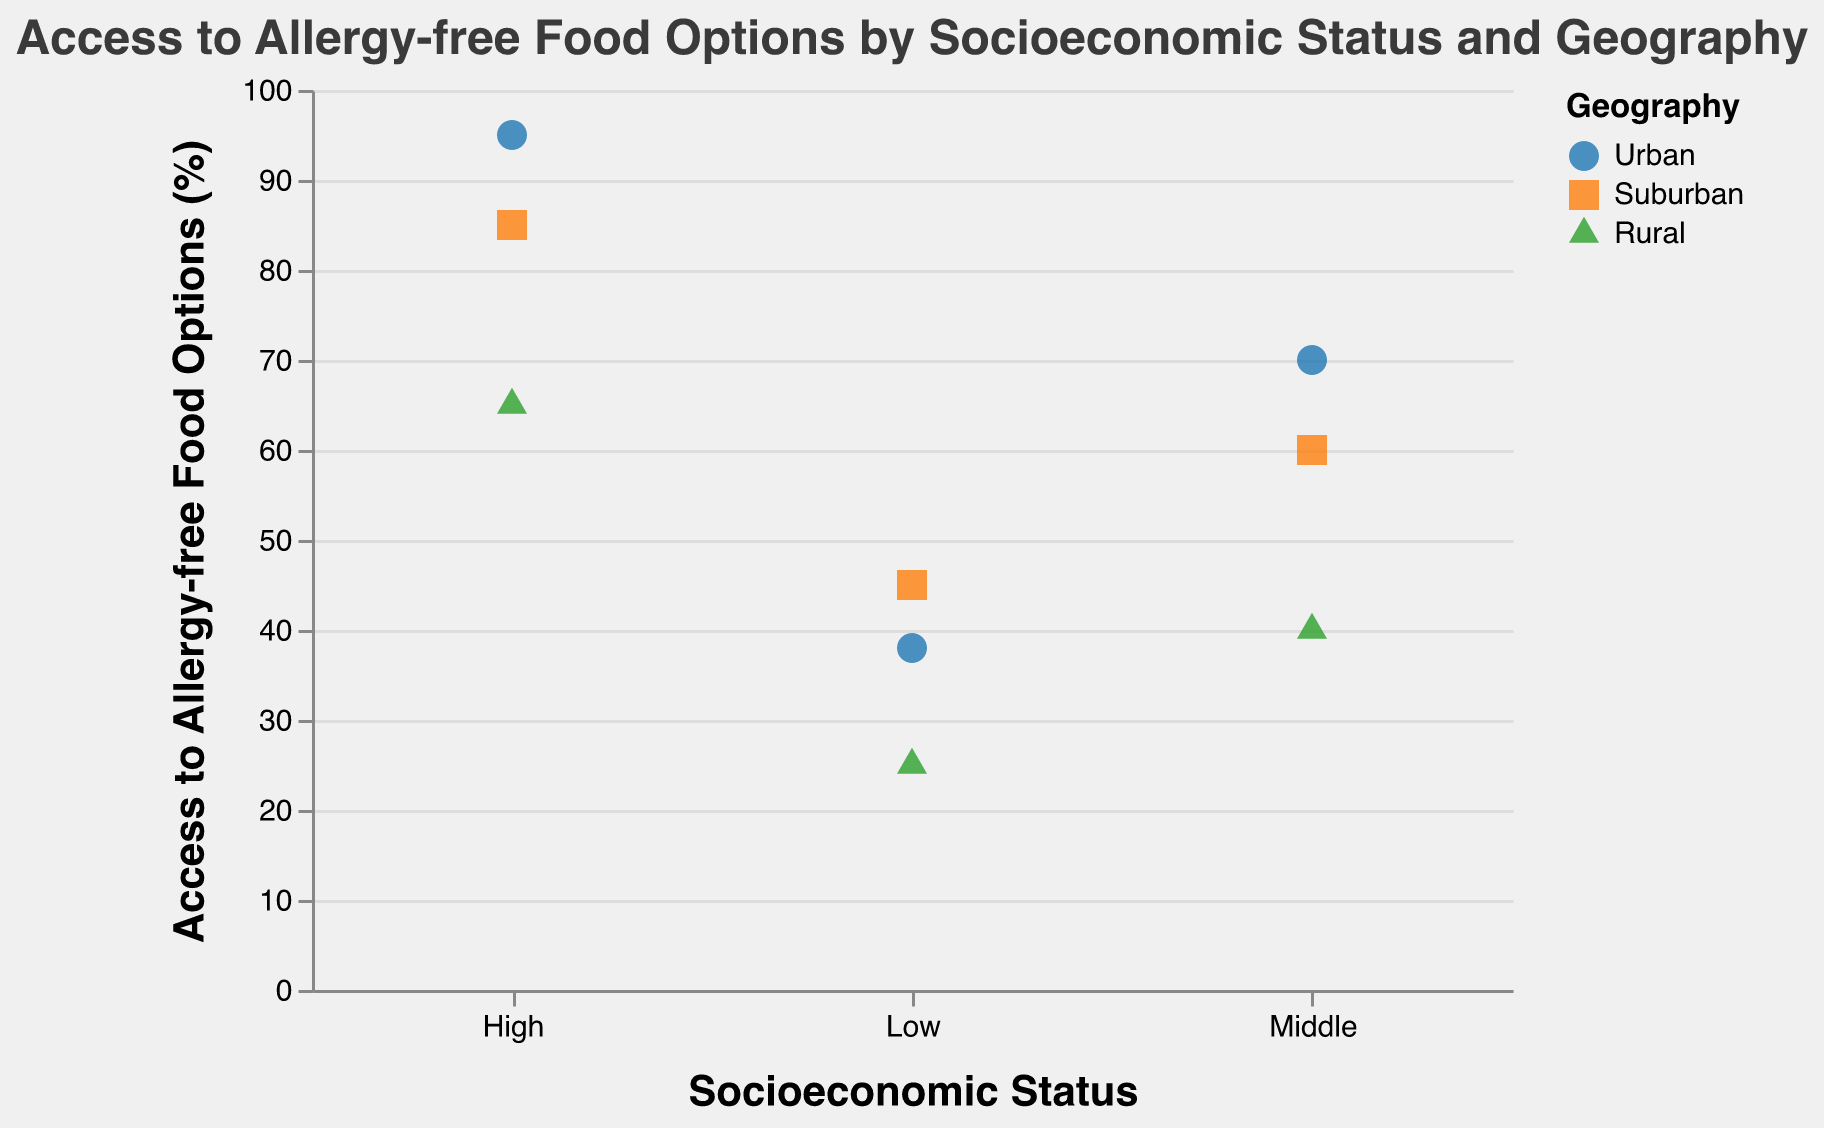What is the title of the figure? The title is located at the top of the figure, centered and reads "Access to Allergy-free Food Options by Socioeconomic Status and Geography".
Answer: Access to Allergy-free Food Options by Socioeconomic Status and Geography How many different socioeconomic statuses are represented in the figure? By looking at the x-axis of the figure, we can see that there are three categories listed: Low, Middle, and High.
Answer: Three Which socioeconomic status has the highest access to allergy-free food options in urban areas? By examining the points under the 'Urban' category and comparing them in each socioeconomic status, we can see the highest point at the 'High' status.
Answer: High What is the difference in access to allergy-free food options between the suburban areas for middle and high socioeconomic status? The figure shows that middle socioeconomic status in suburban areas has 60% access, and high socioeconomic status has 85%. The difference is 85 - 60.
Answer: 25% Which geographic area has the lowest access to allergy-free food options for the low socioeconomic status? By comparing the data points for the low socioeconomic status across different geographies, we see that the 'Rural' area has the lowest access (25%).
Answer: Rural Calculate the average access to allergy-free food options for high socioeconomic status across all geography types. The high socioeconomic status has values of 95 (Urban), 85 (Suburban), and 65 (Rural). The average is calculated as (95 + 85 + 65)/3 = 245/3.
Answer: 81.67% Which two geography types have the most similar access levels to allergy-free food options for the middle socioeconomic status? Looking at the data points for the middle socioeconomic status, we can compare Urban (70%), Suburban (60%), and Rural (40%). The closest values are Urban and Suburban.
Answer: Urban and Suburban In which combination of socioeconomic status and geography do we see the maximum access to allergy-free food options? By comparing all points, we can observe that the maximum value (95%) occurs in the high socioeconomic status and urban geography.
Answer: High and Urban Is there any geographic area where the access to allergy-free food options increases as the socioeconomic status increases? By observing the pattern across socioeconomic statuses within each geographic area, we see that in Urban, Suburban, and Rural, the access increases as the socioeconomic status goes from Low to High.
Answer: Yes 